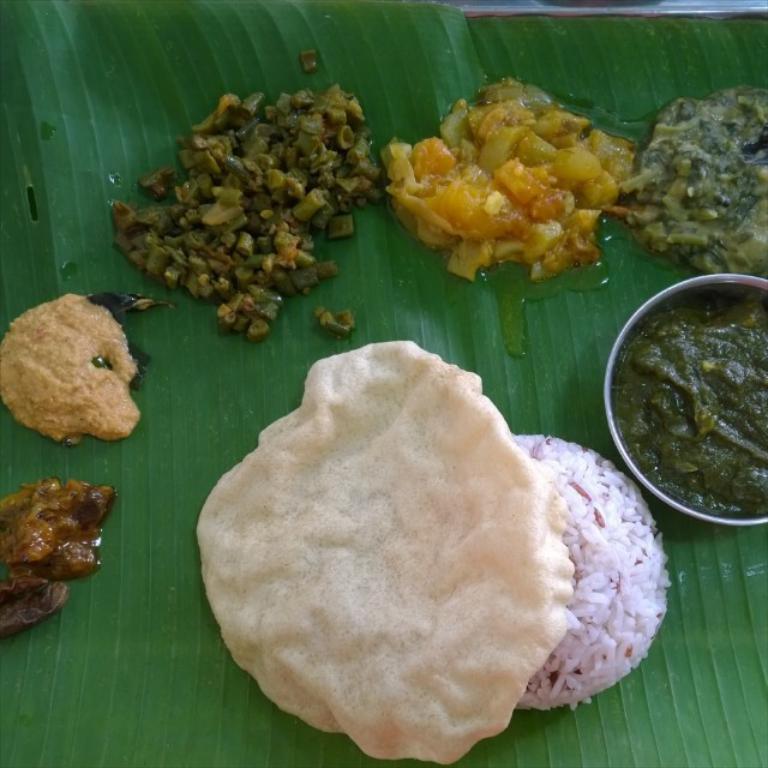Could you give a brief overview of what you see in this image? This picture shows curries and rice and some food in the bowl in the banana leaf. 